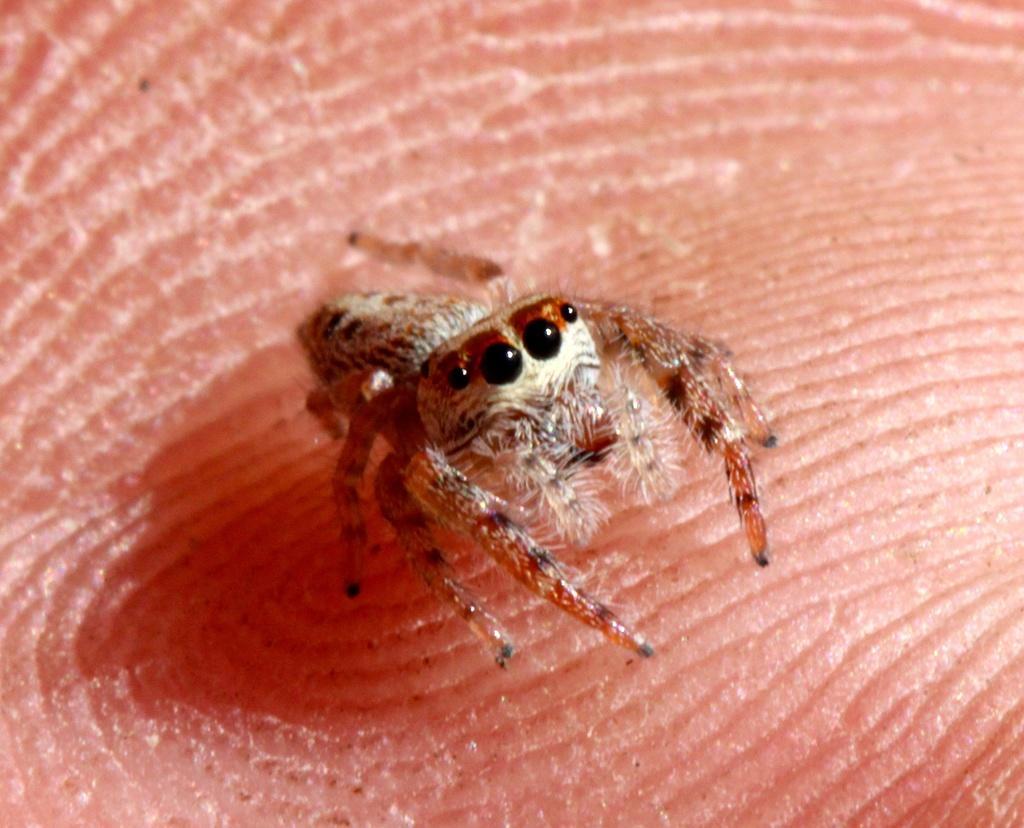In one or two sentences, can you explain what this image depicts? In this image there is a spider on hand. 